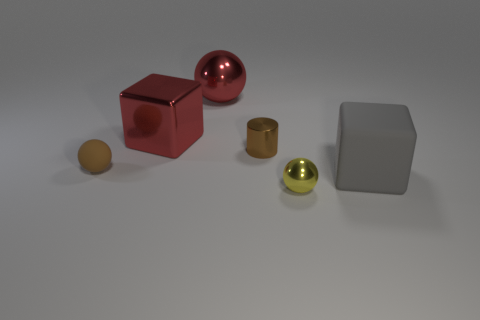There is a metal thing that is both in front of the large red cube and behind the small brown matte ball; how big is it?
Provide a succinct answer. Small. There is a tiny metal sphere that is in front of the large shiny ball; is its color the same as the small rubber ball?
Keep it short and to the point. No. Is the number of brown things in front of the large shiny ball less than the number of metal spheres?
Offer a terse response. No. What is the shape of the small brown thing that is the same material as the yellow object?
Keep it short and to the point. Cylinder. Are the brown ball and the cylinder made of the same material?
Your response must be concise. No. Are there fewer tiny metal spheres that are behind the large rubber object than shiny spheres that are on the left side of the matte ball?
Make the answer very short. No. There is a metal thing that is the same color as the small matte ball; what is its size?
Your response must be concise. Small. There is a block that is behind the cube that is in front of the tiny brown cylinder; what number of big red shiny cubes are behind it?
Offer a terse response. 0. Is the color of the rubber cube the same as the small matte object?
Your answer should be very brief. No. Are there any small metal cylinders that have the same color as the small matte thing?
Offer a terse response. Yes. 